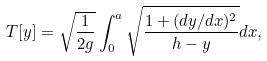Convert formula to latex. <formula><loc_0><loc_0><loc_500><loc_500>T [ y ] = \sqrt { \frac { 1 } { 2 g } } \int _ { 0 } ^ { a } \sqrt { \frac { 1 + ( d y / d x ) ^ { 2 } } { h - y } } d x ,</formula> 